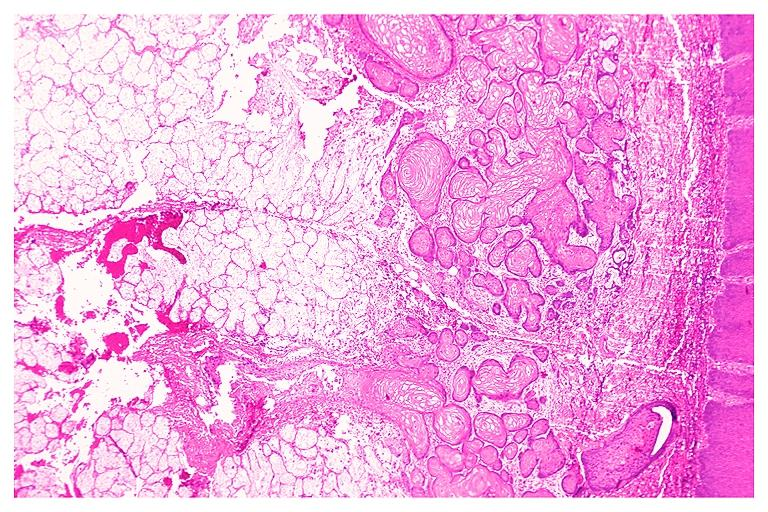s oral present?
Answer the question using a single word or phrase. Yes 